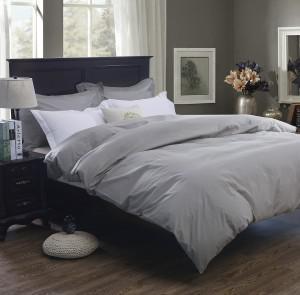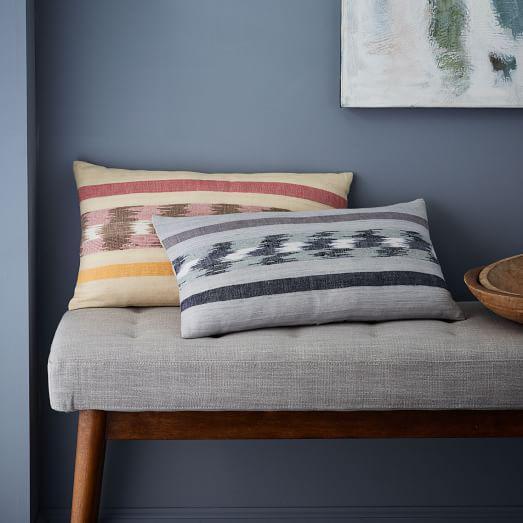The first image is the image on the left, the second image is the image on the right. Evaluate the accuracy of this statement regarding the images: "The image to the left is clearly a bed.". Is it true? Answer yes or no. Yes. The first image is the image on the left, the second image is the image on the right. For the images displayed, is the sentence "An image shows a bed with a blue bedding component and two square non-white pillows facing forward." factually correct? Answer yes or no. No. 